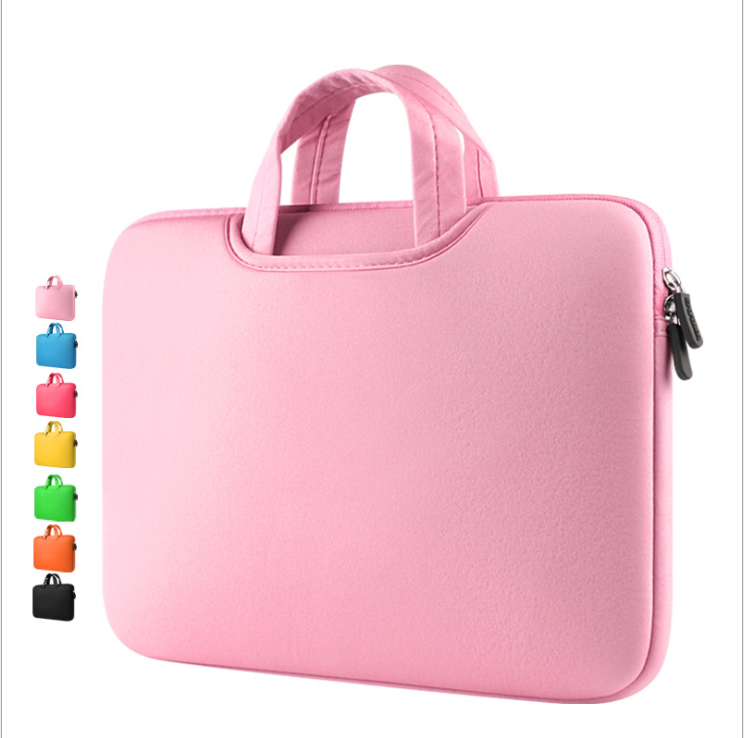What material could the laptop sleeve be made of, and what are its potential protective qualities? The laptop sleeve is likely made from a neoprene-like material, based on its smooth texture and the way it bears a slight sheen. Neoprene is particularly praised for its excellent cushioning abilities, which help safeguard devices against bumps and drops by dissipating the energy of impacts. Additionally, its inherent water resistance protects against spills, making it an asset for users who travel or work in various environments. The choice of neoprene also reflects a balance between lightweight flexibility and substantial protection, ensuring that the sleeve can be easily carried without adding significant bulk or weight. 